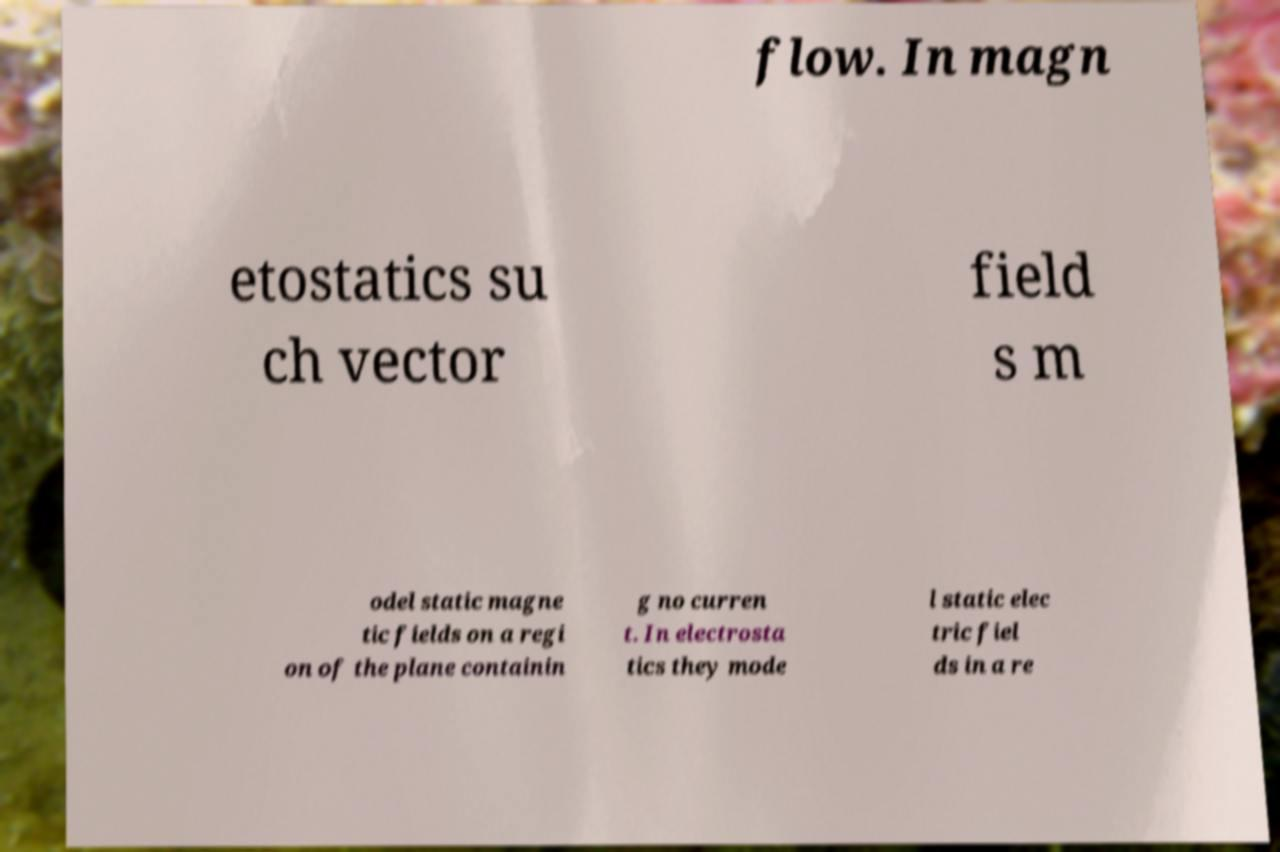Please identify and transcribe the text found in this image. flow. In magn etostatics su ch vector field s m odel static magne tic fields on a regi on of the plane containin g no curren t. In electrosta tics they mode l static elec tric fiel ds in a re 